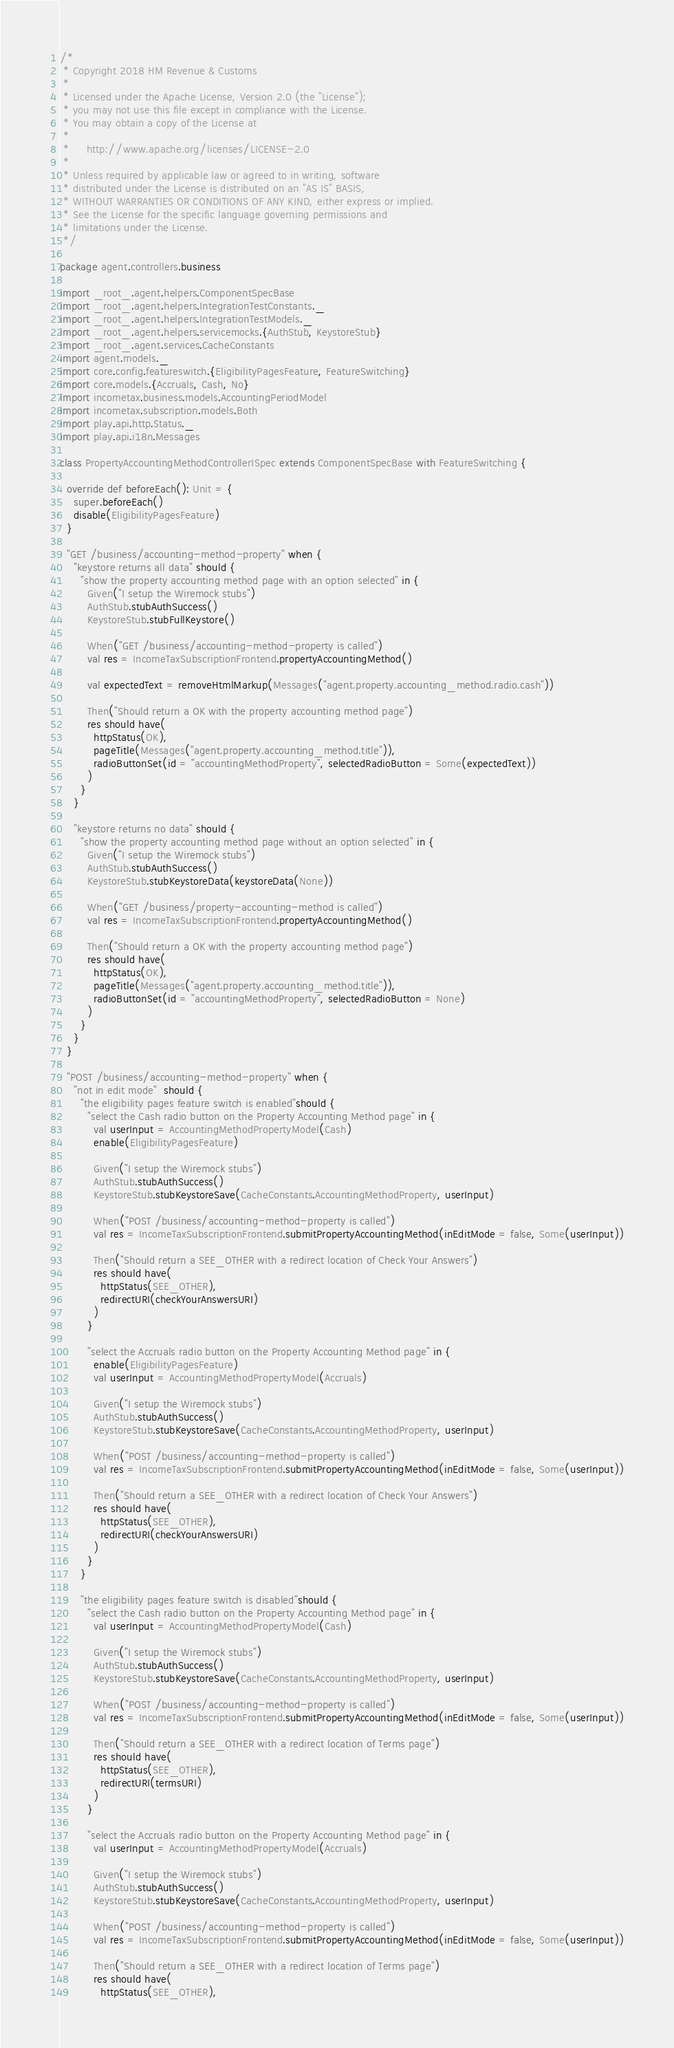<code> <loc_0><loc_0><loc_500><loc_500><_Scala_>/*
 * Copyright 2018 HM Revenue & Customs
 *
 * Licensed under the Apache License, Version 2.0 (the "License");
 * you may not use this file except in compliance with the License.
 * You may obtain a copy of the License at
 *
 *     http://www.apache.org/licenses/LICENSE-2.0
 *
 * Unless required by applicable law or agreed to in writing, software
 * distributed under the License is distributed on an "AS IS" BASIS,
 * WITHOUT WARRANTIES OR CONDITIONS OF ANY KIND, either express or implied.
 * See the License for the specific language governing permissions and
 * limitations under the License.
 */

package agent.controllers.business

import _root_.agent.helpers.ComponentSpecBase
import _root_.agent.helpers.IntegrationTestConstants._
import _root_.agent.helpers.IntegrationTestModels._
import _root_.agent.helpers.servicemocks.{AuthStub, KeystoreStub}
import _root_.agent.services.CacheConstants
import agent.models._
import core.config.featureswitch.{EligibilityPagesFeature, FeatureSwitching}
import core.models.{Accruals, Cash, No}
import incometax.business.models.AccountingPeriodModel
import incometax.subscription.models.Both
import play.api.http.Status._
import play.api.i18n.Messages

class PropertyAccountingMethodControllerISpec extends ComponentSpecBase with FeatureSwitching {

  override def beforeEach(): Unit = {
    super.beforeEach()
    disable(EligibilityPagesFeature)
  }

  "GET /business/accounting-method-property" when {
    "keystore returns all data" should {
      "show the property accounting method page with an option selected" in {
        Given("I setup the Wiremock stubs")
        AuthStub.stubAuthSuccess()
        KeystoreStub.stubFullKeystore()

        When("GET /business/accounting-method-property is called")
        val res = IncomeTaxSubscriptionFrontend.propertyAccountingMethod()

        val expectedText = removeHtmlMarkup(Messages("agent.property.accounting_method.radio.cash"))

        Then("Should return a OK with the property accounting method page")
        res should have(
          httpStatus(OK),
          pageTitle(Messages("agent.property.accounting_method.title")),
          radioButtonSet(id = "accountingMethodProperty", selectedRadioButton = Some(expectedText))
        )
      }
    }

    "keystore returns no data" should {
      "show the property accounting method page without an option selected" in {
        Given("I setup the Wiremock stubs")
        AuthStub.stubAuthSuccess()
        KeystoreStub.stubKeystoreData(keystoreData(None))

        When("GET /business/property-accounting-method is called")
        val res = IncomeTaxSubscriptionFrontend.propertyAccountingMethod()

        Then("Should return a OK with the property accounting method page")
        res should have(
          httpStatus(OK),
          pageTitle(Messages("agent.property.accounting_method.title")),
          radioButtonSet(id = "accountingMethodProperty", selectedRadioButton = None)
        )
      }
    }
  }

  "POST /business/accounting-method-property" when {
    "not in edit mode"  should {
      "the eligibility pages feature switch is enabled"should {
        "select the Cash radio button on the Property Accounting Method page" in {
          val userInput = AccountingMethodPropertyModel(Cash)
          enable(EligibilityPagesFeature)

          Given("I setup the Wiremock stubs")
          AuthStub.stubAuthSuccess()
          KeystoreStub.stubKeystoreSave(CacheConstants.AccountingMethodProperty, userInput)

          When("POST /business/accounting-method-property is called")
          val res = IncomeTaxSubscriptionFrontend.submitPropertyAccountingMethod(inEditMode = false, Some(userInput))

          Then("Should return a SEE_OTHER with a redirect location of Check Your Answers")
          res should have(
            httpStatus(SEE_OTHER),
            redirectURI(checkYourAnswersURI)
          )
        }

        "select the Accruals radio button on the Property Accounting Method page" in {
          enable(EligibilityPagesFeature)
          val userInput = AccountingMethodPropertyModel(Accruals)

          Given("I setup the Wiremock stubs")
          AuthStub.stubAuthSuccess()
          KeystoreStub.stubKeystoreSave(CacheConstants.AccountingMethodProperty, userInput)

          When("POST /business/accounting-method-property is called")
          val res = IncomeTaxSubscriptionFrontend.submitPropertyAccountingMethod(inEditMode = false, Some(userInput))

          Then("Should return a SEE_OTHER with a redirect location of Check Your Answers")
          res should have(
            httpStatus(SEE_OTHER),
            redirectURI(checkYourAnswersURI)
          )
        }
      }

      "the eligibility pages feature switch is disabled"should {
        "select the Cash radio button on the Property Accounting Method page" in {
          val userInput = AccountingMethodPropertyModel(Cash)

          Given("I setup the Wiremock stubs")
          AuthStub.stubAuthSuccess()
          KeystoreStub.stubKeystoreSave(CacheConstants.AccountingMethodProperty, userInput)

          When("POST /business/accounting-method-property is called")
          val res = IncomeTaxSubscriptionFrontend.submitPropertyAccountingMethod(inEditMode = false, Some(userInput))

          Then("Should return a SEE_OTHER with a redirect location of Terms page")
          res should have(
            httpStatus(SEE_OTHER),
            redirectURI(termsURI)
          )
        }

        "select the Accruals radio button on the Property Accounting Method page" in {
          val userInput = AccountingMethodPropertyModel(Accruals)

          Given("I setup the Wiremock stubs")
          AuthStub.stubAuthSuccess()
          KeystoreStub.stubKeystoreSave(CacheConstants.AccountingMethodProperty, userInput)

          When("POST /business/accounting-method-property is called")
          val res = IncomeTaxSubscriptionFrontend.submitPropertyAccountingMethod(inEditMode = false, Some(userInput))

          Then("Should return a SEE_OTHER with a redirect location of Terms page")
          res should have(
            httpStatus(SEE_OTHER),</code> 